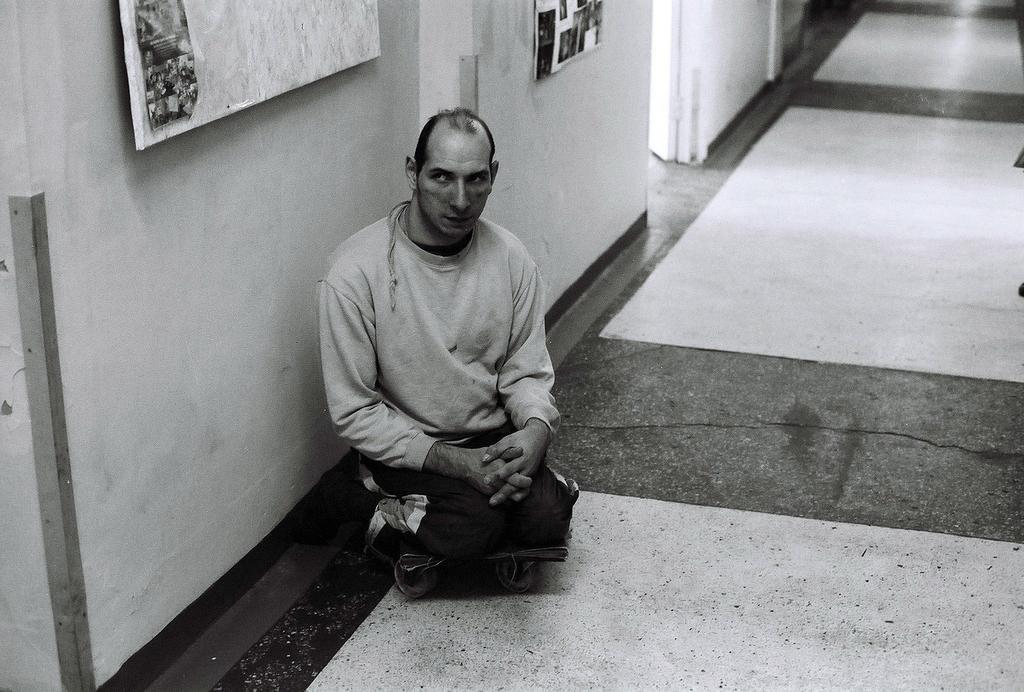How would you summarize this image in a sentence or two? In this image we can see a person sitting on a trolley, there is a wall, on that there are two boards, and the picture is taken in black and white mode. 